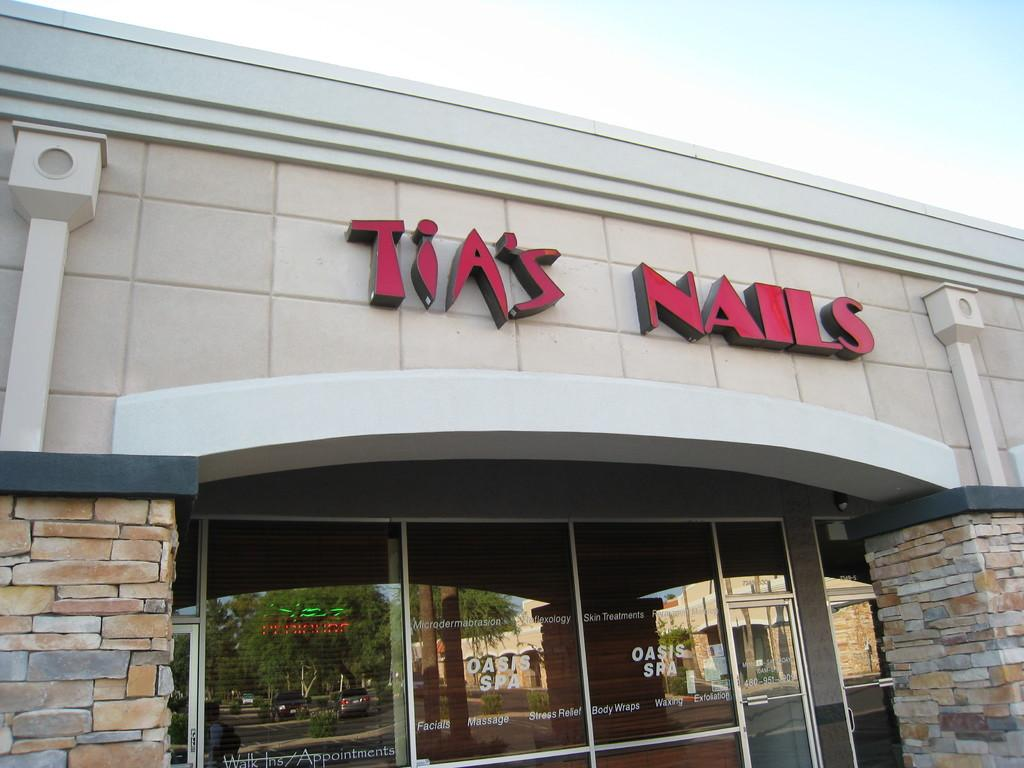What type of establishment is depicted in the image? There is a store in the image. Can you describe any text or writing on the store? Yes, there is writing on the store. What type of pen is being used by the army in the image? There is no pen or army present in the image; it only features a store with writing on it. 